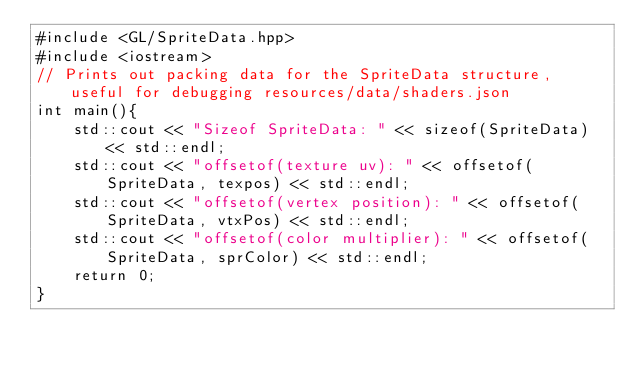<code> <loc_0><loc_0><loc_500><loc_500><_C++_>#include <GL/SpriteData.hpp>
#include <iostream>
// Prints out packing data for the SpriteData structure, useful for debugging resources/data/shaders.json
int main(){
	std::cout << "Sizeof SpriteData: " << sizeof(SpriteData) << std::endl;
	std::cout << "offsetof(texture uv): " << offsetof(SpriteData, texpos) << std::endl;
	std::cout << "offsetof(vertex position): " << offsetof(SpriteData, vtxPos) << std::endl;
	std::cout << "offsetof(color multiplier): " << offsetof(SpriteData, sprColor) << std::endl;
	return 0;
}
</code> 